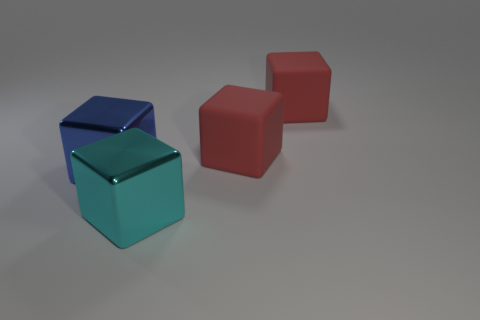The metallic thing that is the same size as the cyan metal block is what shape?
Make the answer very short. Cube. What number of objects are either blue metallic objects or metal things behind the big cyan metallic object?
Provide a short and direct response. 1. There is a cyan block; what number of red objects are left of it?
Offer a very short reply. 0. The thing that is the same material as the cyan cube is what color?
Offer a terse response. Blue. What number of matte objects are either blocks or big red things?
Offer a terse response. 2. Are the large blue cube and the large cyan block made of the same material?
Give a very brief answer. Yes. Is there a shiny cube to the left of the metal object behind the cyan metal thing?
Offer a terse response. No. Are there any metallic objects that have the same size as the blue shiny block?
Offer a terse response. Yes. How big is the blue thing?
Give a very brief answer. Large. There is a block in front of the large metallic object that is left of the big cyan shiny thing; what size is it?
Your answer should be compact. Large. 